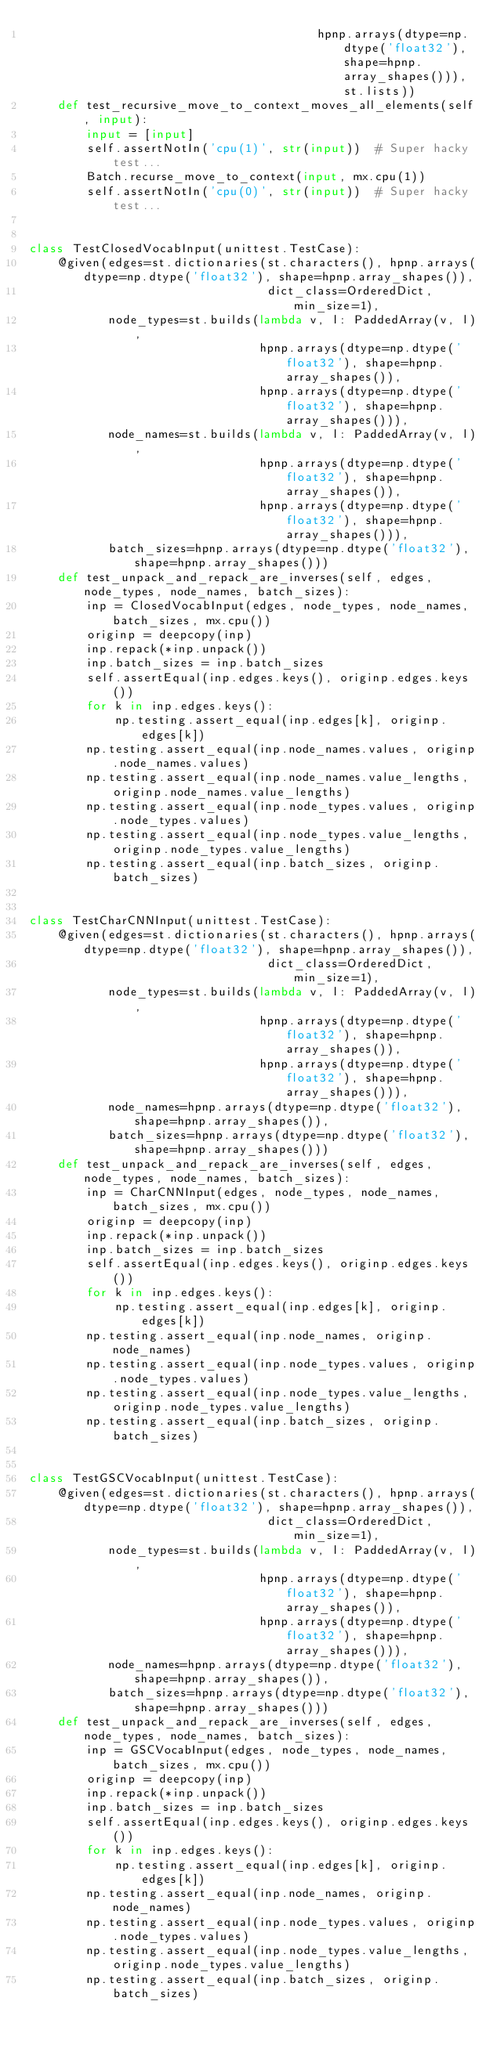Convert code to text. <code><loc_0><loc_0><loc_500><loc_500><_Python_>                                        hpnp.arrays(dtype=np.dtype('float32'), shape=hpnp.array_shapes())), st.lists))
    def test_recursive_move_to_context_moves_all_elements(self, input):
        input = [input]
        self.assertNotIn('cpu(1)', str(input))  # Super hacky test...
        Batch.recurse_move_to_context(input, mx.cpu(1))
        self.assertNotIn('cpu(0)', str(input))  # Super hacky test...


class TestClosedVocabInput(unittest.TestCase):
    @given(edges=st.dictionaries(st.characters(), hpnp.arrays(dtype=np.dtype('float32'), shape=hpnp.array_shapes()),
                                 dict_class=OrderedDict, min_size=1),
           node_types=st.builds(lambda v, l: PaddedArray(v, l),
                                hpnp.arrays(dtype=np.dtype('float32'), shape=hpnp.array_shapes()),
                                hpnp.arrays(dtype=np.dtype('float32'), shape=hpnp.array_shapes())),
           node_names=st.builds(lambda v, l: PaddedArray(v, l),
                                hpnp.arrays(dtype=np.dtype('float32'), shape=hpnp.array_shapes()),
                                hpnp.arrays(dtype=np.dtype('float32'), shape=hpnp.array_shapes())),
           batch_sizes=hpnp.arrays(dtype=np.dtype('float32'), shape=hpnp.array_shapes()))
    def test_unpack_and_repack_are_inverses(self, edges, node_types, node_names, batch_sizes):
        inp = ClosedVocabInput(edges, node_types, node_names, batch_sizes, mx.cpu())
        originp = deepcopy(inp)
        inp.repack(*inp.unpack())
        inp.batch_sizes = inp.batch_sizes
        self.assertEqual(inp.edges.keys(), originp.edges.keys())
        for k in inp.edges.keys():
            np.testing.assert_equal(inp.edges[k], originp.edges[k])
        np.testing.assert_equal(inp.node_names.values, originp.node_names.values)
        np.testing.assert_equal(inp.node_names.value_lengths, originp.node_names.value_lengths)
        np.testing.assert_equal(inp.node_types.values, originp.node_types.values)
        np.testing.assert_equal(inp.node_types.value_lengths, originp.node_types.value_lengths)
        np.testing.assert_equal(inp.batch_sizes, originp.batch_sizes)


class TestCharCNNInput(unittest.TestCase):
    @given(edges=st.dictionaries(st.characters(), hpnp.arrays(dtype=np.dtype('float32'), shape=hpnp.array_shapes()),
                                 dict_class=OrderedDict, min_size=1),
           node_types=st.builds(lambda v, l: PaddedArray(v, l),
                                hpnp.arrays(dtype=np.dtype('float32'), shape=hpnp.array_shapes()),
                                hpnp.arrays(dtype=np.dtype('float32'), shape=hpnp.array_shapes())),
           node_names=hpnp.arrays(dtype=np.dtype('float32'), shape=hpnp.array_shapes()),
           batch_sizes=hpnp.arrays(dtype=np.dtype('float32'), shape=hpnp.array_shapes()))
    def test_unpack_and_repack_are_inverses(self, edges, node_types, node_names, batch_sizes):
        inp = CharCNNInput(edges, node_types, node_names, batch_sizes, mx.cpu())
        originp = deepcopy(inp)
        inp.repack(*inp.unpack())
        inp.batch_sizes = inp.batch_sizes
        self.assertEqual(inp.edges.keys(), originp.edges.keys())
        for k in inp.edges.keys():
            np.testing.assert_equal(inp.edges[k], originp.edges[k])
        np.testing.assert_equal(inp.node_names, originp.node_names)
        np.testing.assert_equal(inp.node_types.values, originp.node_types.values)
        np.testing.assert_equal(inp.node_types.value_lengths, originp.node_types.value_lengths)
        np.testing.assert_equal(inp.batch_sizes, originp.batch_sizes)


class TestGSCVocabInput(unittest.TestCase):
    @given(edges=st.dictionaries(st.characters(), hpnp.arrays(dtype=np.dtype('float32'), shape=hpnp.array_shapes()),
                                 dict_class=OrderedDict, min_size=1),
           node_types=st.builds(lambda v, l: PaddedArray(v, l),
                                hpnp.arrays(dtype=np.dtype('float32'), shape=hpnp.array_shapes()),
                                hpnp.arrays(dtype=np.dtype('float32'), shape=hpnp.array_shapes())),
           node_names=hpnp.arrays(dtype=np.dtype('float32'), shape=hpnp.array_shapes()),
           batch_sizes=hpnp.arrays(dtype=np.dtype('float32'), shape=hpnp.array_shapes()))
    def test_unpack_and_repack_are_inverses(self, edges, node_types, node_names, batch_sizes):
        inp = GSCVocabInput(edges, node_types, node_names, batch_sizes, mx.cpu())
        originp = deepcopy(inp)
        inp.repack(*inp.unpack())
        inp.batch_sizes = inp.batch_sizes
        self.assertEqual(inp.edges.keys(), originp.edges.keys())
        for k in inp.edges.keys():
            np.testing.assert_equal(inp.edges[k], originp.edges[k])
        np.testing.assert_equal(inp.node_names, originp.node_names)
        np.testing.assert_equal(inp.node_types.values, originp.node_types.values)
        np.testing.assert_equal(inp.node_types.value_lengths, originp.node_types.value_lengths)
        np.testing.assert_equal(inp.batch_sizes, originp.batch_sizes)
</code> 